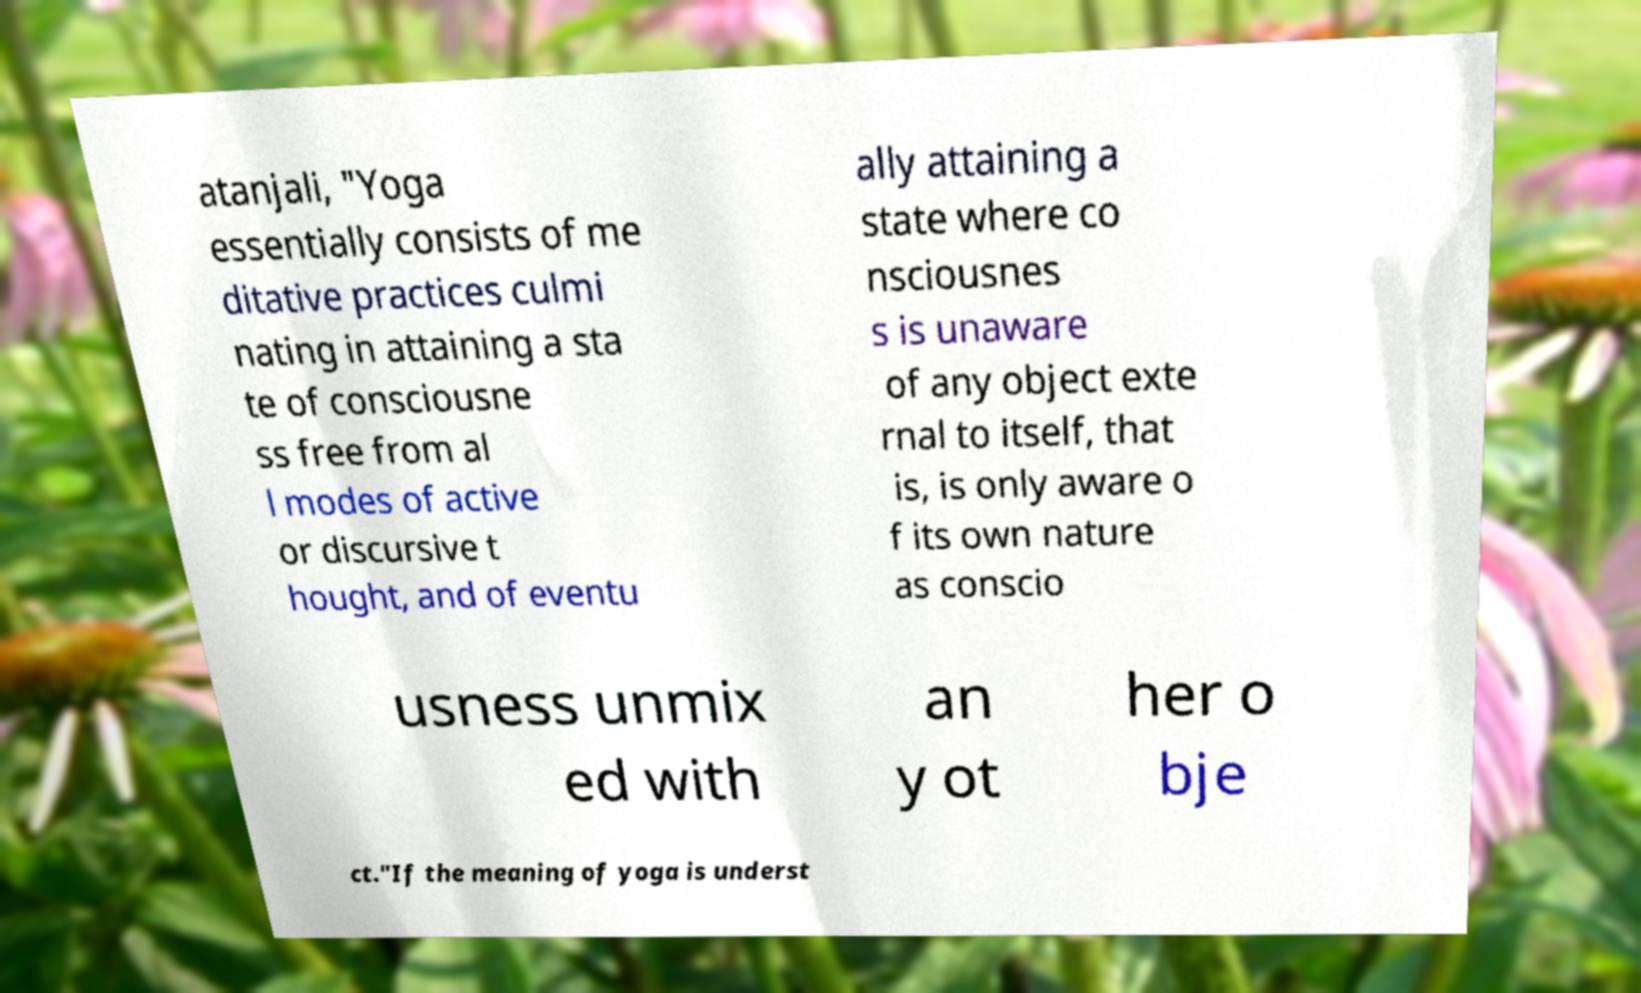Could you assist in decoding the text presented in this image and type it out clearly? atanjali, "Yoga essentially consists of me ditative practices culmi nating in attaining a sta te of consciousne ss free from al l modes of active or discursive t hought, and of eventu ally attaining a state where co nsciousnes s is unaware of any object exte rnal to itself, that is, is only aware o f its own nature as conscio usness unmix ed with an y ot her o bje ct."If the meaning of yoga is underst 